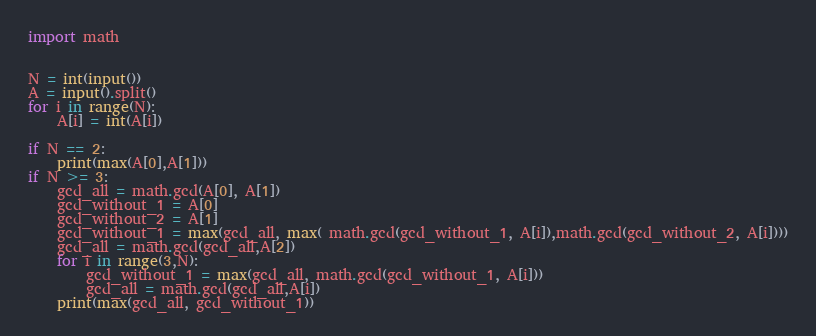<code> <loc_0><loc_0><loc_500><loc_500><_Python_>import math


N = int(input())
A = input().split()
for i in range(N):
    A[i] = int(A[i])
    
if N == 2:
    print(max(A[0],A[1]))
if N >= 3:
    gcd_all = math.gcd(A[0], A[1])
    gcd_without_1 = A[0]
    gcd_without_2 = A[1]
    gcd_without_1 = max(gcd_all, max( math.gcd(gcd_without_1, A[i]),math.gcd(gcd_without_2, A[i])))
    gcd_all = math.gcd(gcd_all,A[2])
    for i in range(3,N):
        gcd_without_1 = max(gcd_all, math.gcd(gcd_without_1, A[i]))
        gcd_all = math.gcd(gcd_all,A[i])
    print(max(gcd_all, gcd_without_1))



</code> 